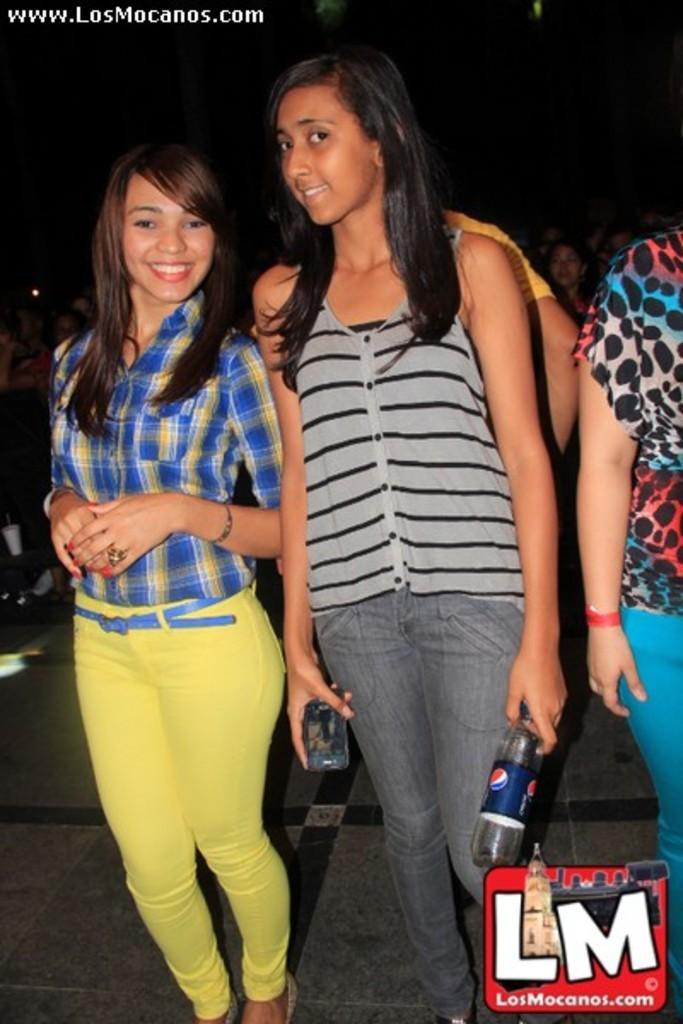Could you give a brief overview of what you see in this image? In this image we can see a group of people standing on the ground. One woman is holding a mobile in her and a bottle in the other hand. On the left side of the image we can see a cup placed on the surface. At the bottom we can see a logo with some text. 